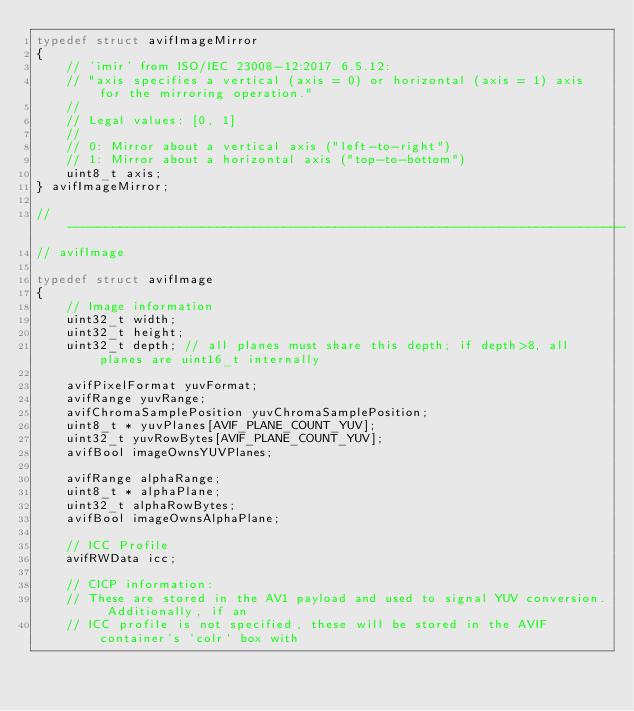Convert code to text. <code><loc_0><loc_0><loc_500><loc_500><_C_>typedef struct avifImageMirror
{
    // 'imir' from ISO/IEC 23008-12:2017 6.5.12:
    // "axis specifies a vertical (axis = 0) or horizontal (axis = 1) axis for the mirroring operation."
    //
    // Legal values: [0, 1]
    //
    // 0: Mirror about a vertical axis ("left-to-right")
    // 1: Mirror about a horizontal axis ("top-to-bottom")
    uint8_t axis;
} avifImageMirror;

// ---------------------------------------------------------------------------
// avifImage

typedef struct avifImage
{
    // Image information
    uint32_t width;
    uint32_t height;
    uint32_t depth; // all planes must share this depth; if depth>8, all planes are uint16_t internally

    avifPixelFormat yuvFormat;
    avifRange yuvRange;
    avifChromaSamplePosition yuvChromaSamplePosition;
    uint8_t * yuvPlanes[AVIF_PLANE_COUNT_YUV];
    uint32_t yuvRowBytes[AVIF_PLANE_COUNT_YUV];
    avifBool imageOwnsYUVPlanes;

    avifRange alphaRange;
    uint8_t * alphaPlane;
    uint32_t alphaRowBytes;
    avifBool imageOwnsAlphaPlane;

    // ICC Profile
    avifRWData icc;

    // CICP information:
    // These are stored in the AV1 payload and used to signal YUV conversion. Additionally, if an
    // ICC profile is not specified, these will be stored in the AVIF container's `colr` box with</code> 